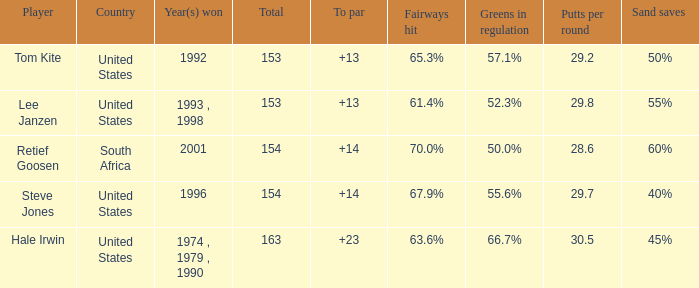Parse the table in full. {'header': ['Player', 'Country', 'Year(s) won', 'Total', 'To par', 'Fairways hit', 'Greens in regulation', 'Putts per round', 'Sand saves '], 'rows': [['Tom Kite', 'United States', '1992', '153', '+13', '65.3%', '57.1%', '29.2', '50%'], ['Lee Janzen', 'United States', '1993 , 1998', '153', '+13', '61.4%', '52.3%', '29.8', '55%'], ['Retief Goosen', 'South Africa', '2001', '154', '+14', '70.0%', '50.0%', '28.6', '60%'], ['Steve Jones', 'United States', '1996', '154', '+14', '67.9%', '55.6%', '29.7', '40%'], ['Hale Irwin', 'United States', '1974 , 1979 , 1990', '163', '+23', '63.6%', '66.7%', '30.5', '45%']]} What is the total that South Africa had a par greater than 14 None. 